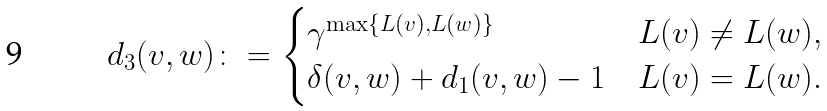<formula> <loc_0><loc_0><loc_500><loc_500>d _ { 3 } ( v , w ) \colon = \begin{cases} \gamma ^ { \max \{ L ( v ) , L ( w ) \} } & L ( v ) \neq L ( w ) , \\ \delta ( v , w ) + d _ { 1 } ( v , w ) - 1 & L ( v ) = L ( w ) . \end{cases}</formula> 